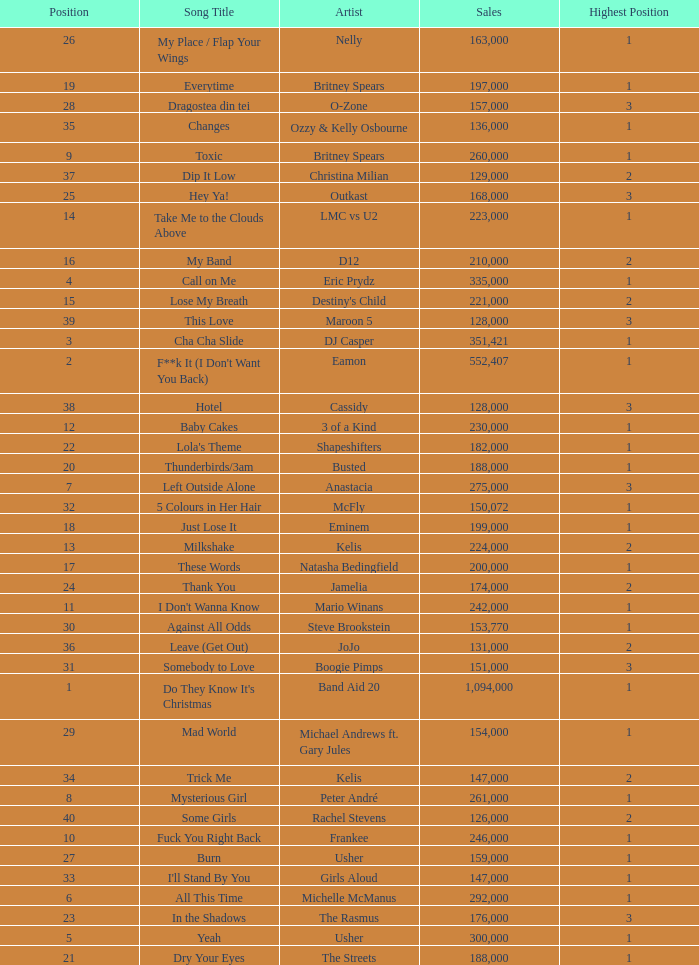What is the most sales by a song with a position higher than 3? None. 